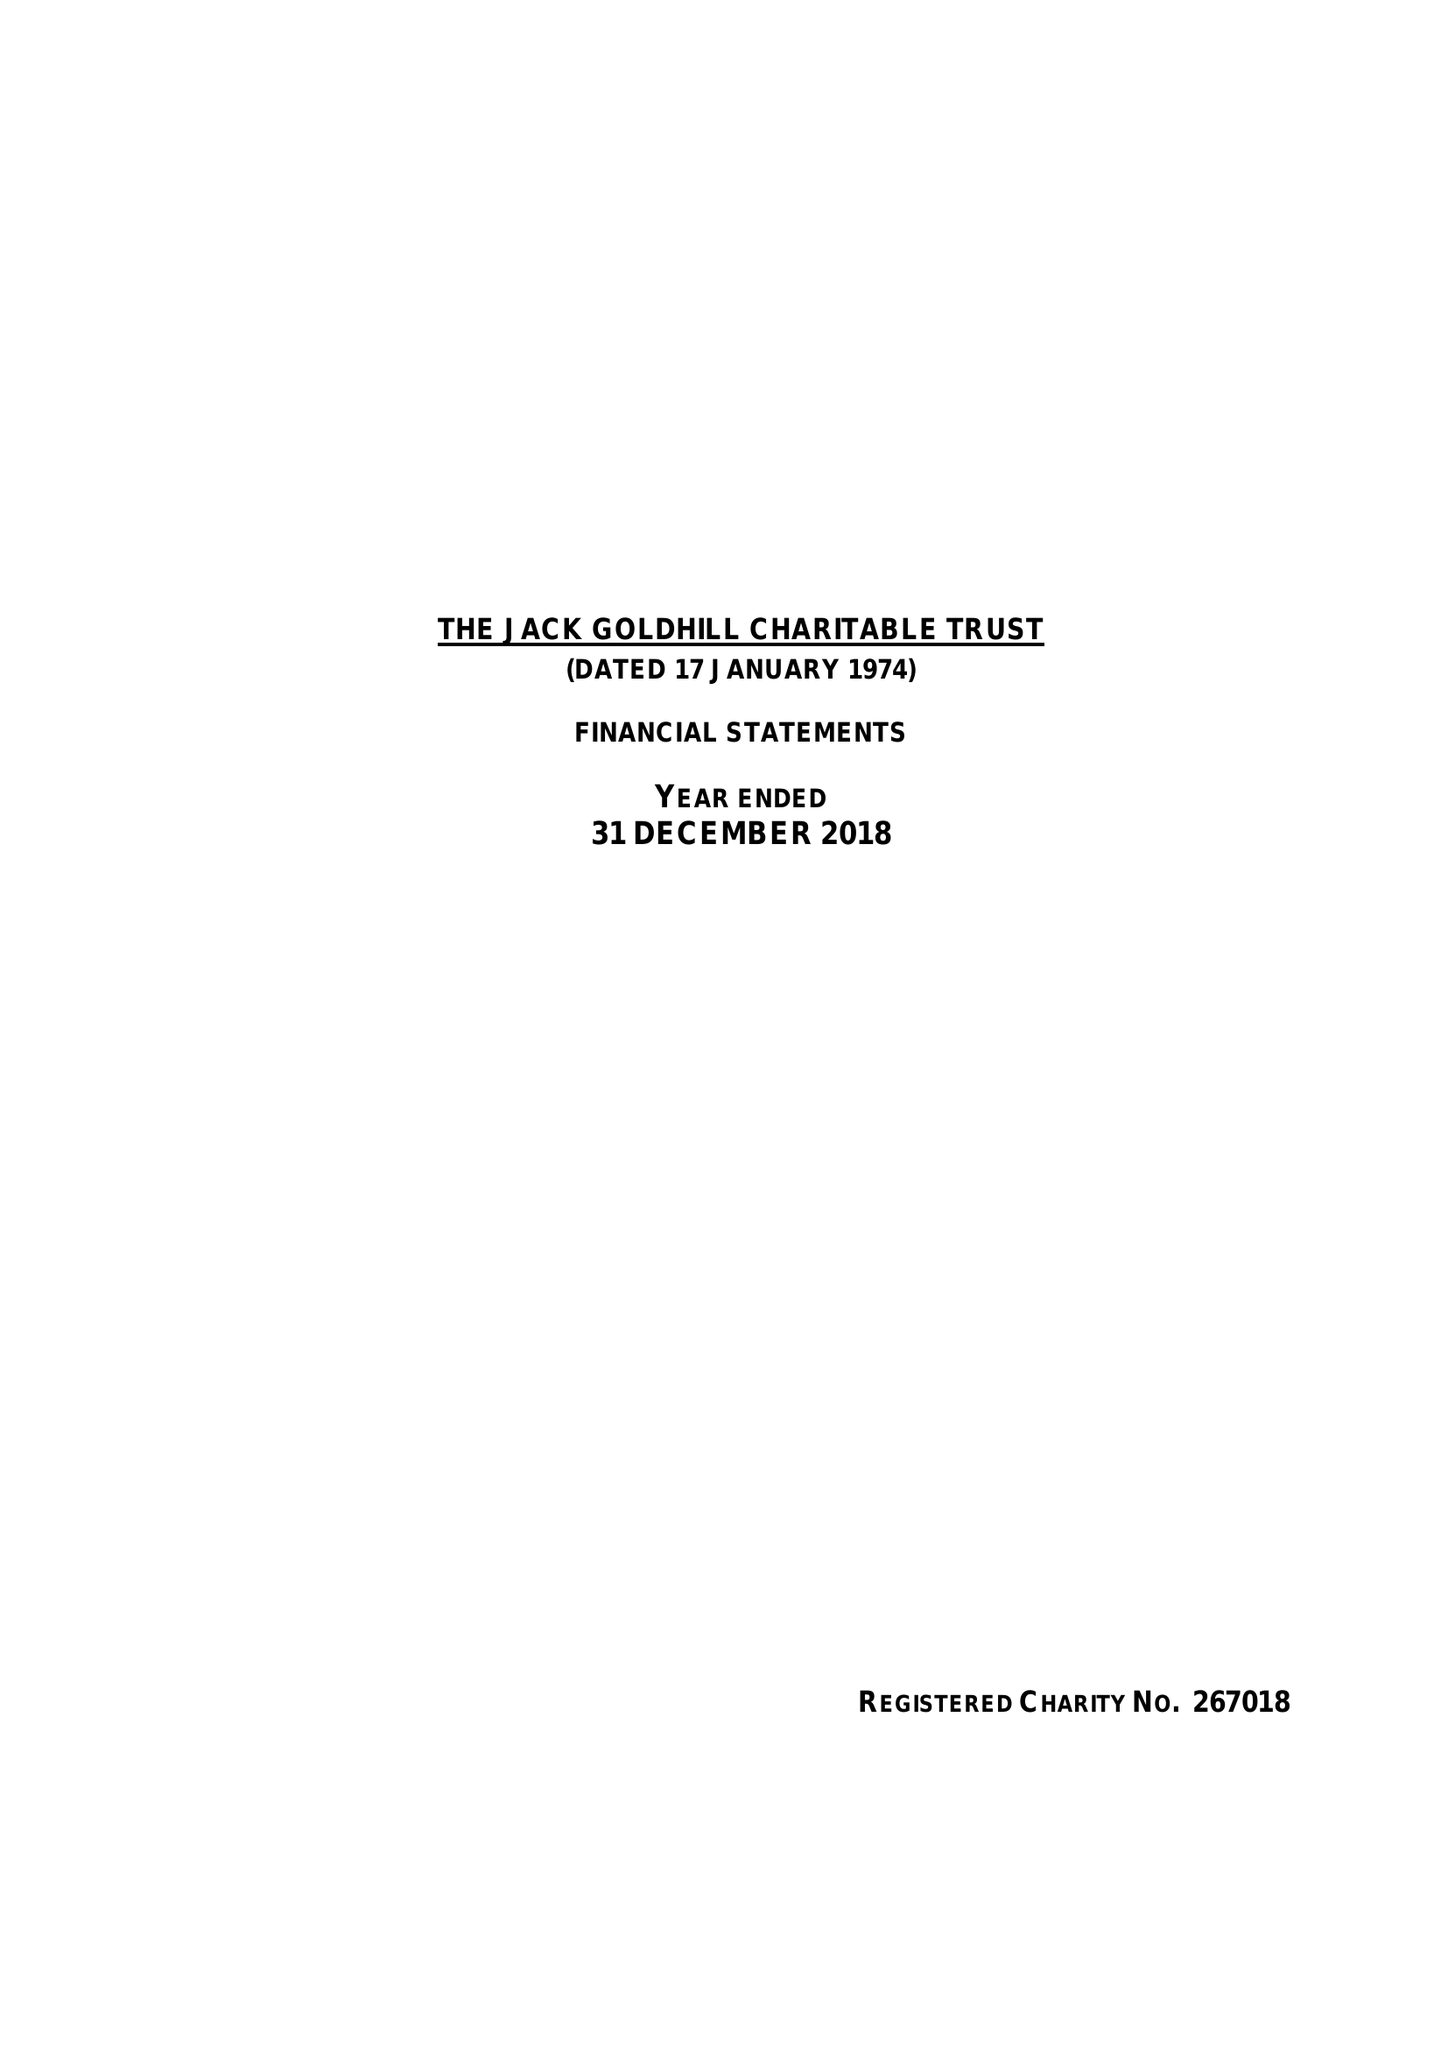What is the value for the charity_name?
Answer the question using a single word or phrase. Jack Goldhill Charitable Trust 